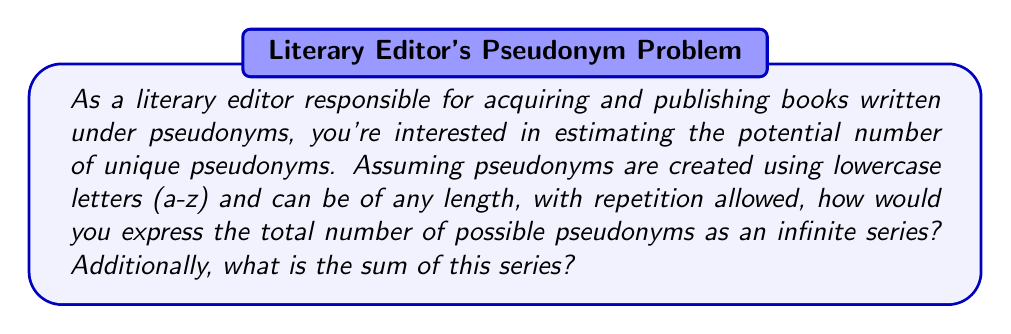Help me with this question. Let's approach this step-by-step:

1) First, let's consider the number of pseudonyms for each length:
   - 1 letter pseudonyms: $26^1$
   - 2 letter pseudonyms: $26^2$
   - 3 letter pseudonyms: $26^3$
   ... and so on

2) We can express this as an infinite series:

   $$S = 26^1 + 26^2 + 26^3 + 26^4 + ...$$

3) This is a geometric series with first term $a = 26$ and common ratio $r = 26$

4) The sum of an infinite geometric series with $|r| > 1$ is given by the formula:

   $$S = \frac{a}{1-r}$$

   where $a$ is the first term and $r$ is the common ratio.

5) In our case, $a = 26$ and $r = 26$. Substituting these values:

   $$S = \frac{26}{1-26} = \frac{26}{-25} = -\frac{26}{25}$$

6) However, since we're counting pseudonyms, we need the absolute value of this result.

Therefore, the total number of potential pseudonyms is $\frac{26}{25}$.
Answer: The infinite series representing the number of potential pseudonyms is:

$$26^1 + 26^2 + 26^3 + 26^4 + ...$$

The sum of this series is $\frac{26}{25}$. 